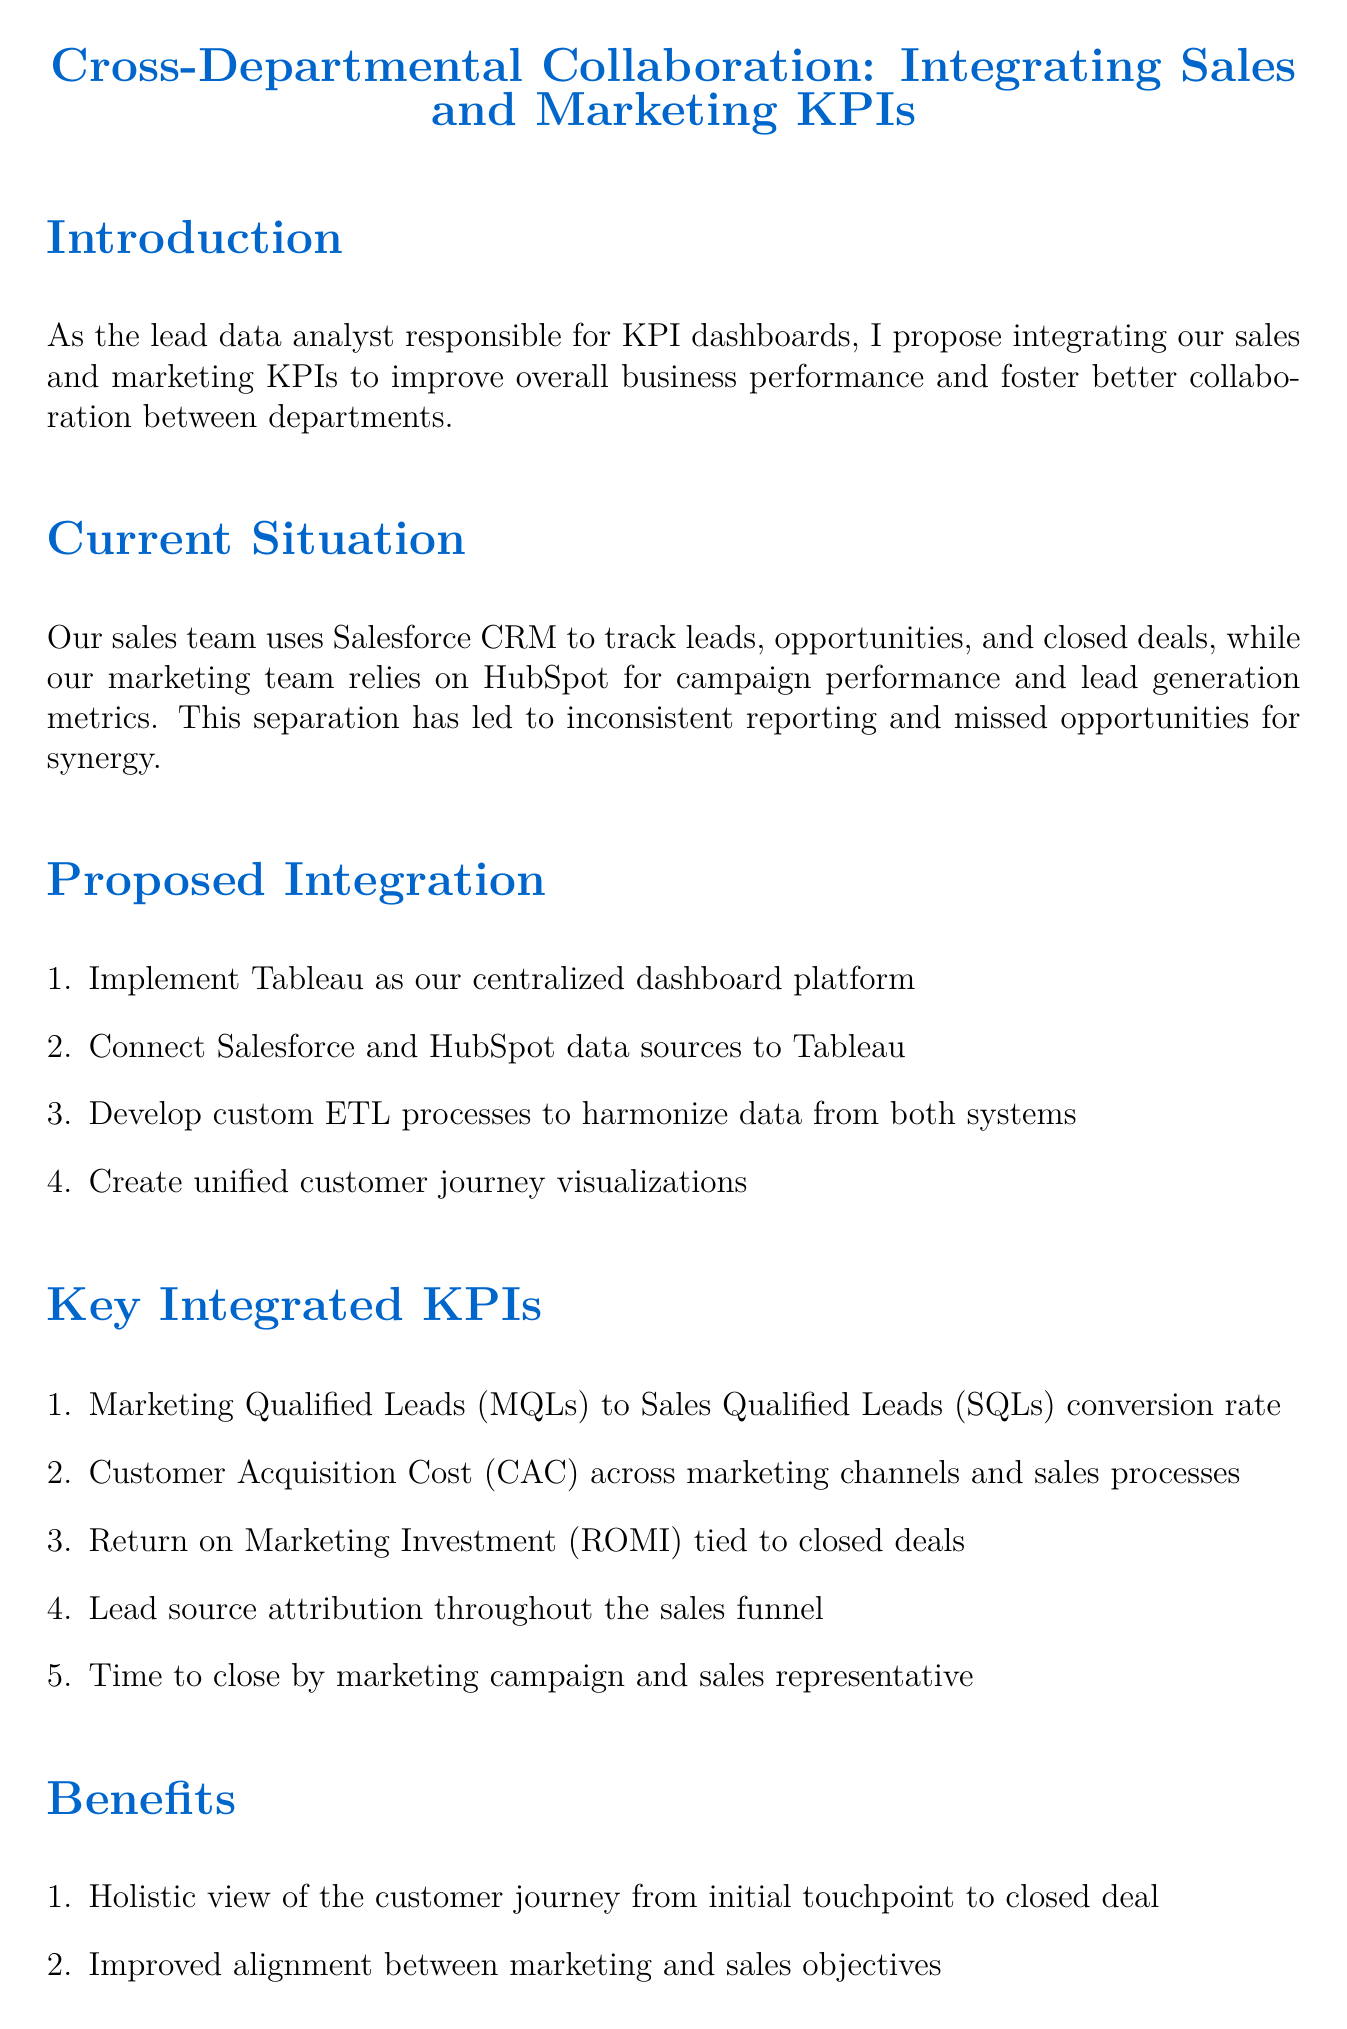What is the title of the memo? The title of the memo is provided in the document's header section.
Answer: Cross-Departmental Collaboration: Integrating Sales and Marketing KPIs Who is the author of the memo? The author is listed at the footer of the document.
Answer: Alex Rodriguez What is the date of the memo? The date of the memo is specified in the footer.
Answer: May 15, 2023 What software is proposed for the centralized dashboard platform? The software proposed for the centralized dashboard is mentioned in the proposed integration section.
Answer: Tableau What is one of the key integrated KPIs mentioned? The key integrated KPIs are listed in the corresponding section.
Answer: Marketing Qualified Leads (MQLs) to Sales Qualified Leads (SQLs) conversion rate How many weeks are allocated for user acceptance testing? The implementation timeline section outlines this detail.
Answer: 1 week What is the first step in the implementation timeline? The implementation timeline outlines specific steps sequentially.
Answer: Requirements gathering and system analysis Who should be included in the kick-off meeting? The next steps section names the individuals recommended for the meeting.
Answer: Jennifer Torres, Michael Chen, Sarah Johnson What is one benefit of integrating sales and marketing KPIs? The benefits of integration are described in the document's benefits section.
Answer: Improved alignment between marketing and sales objectives 